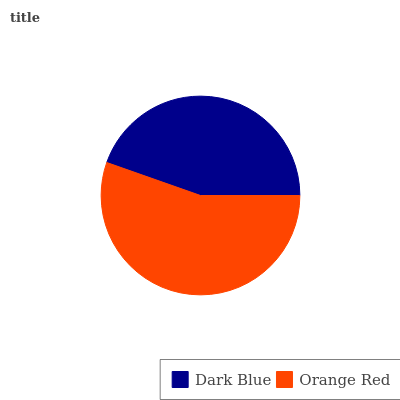Is Dark Blue the minimum?
Answer yes or no. Yes. Is Orange Red the maximum?
Answer yes or no. Yes. Is Orange Red the minimum?
Answer yes or no. No. Is Orange Red greater than Dark Blue?
Answer yes or no. Yes. Is Dark Blue less than Orange Red?
Answer yes or no. Yes. Is Dark Blue greater than Orange Red?
Answer yes or no. No. Is Orange Red less than Dark Blue?
Answer yes or no. No. Is Orange Red the high median?
Answer yes or no. Yes. Is Dark Blue the low median?
Answer yes or no. Yes. Is Dark Blue the high median?
Answer yes or no. No. Is Orange Red the low median?
Answer yes or no. No. 